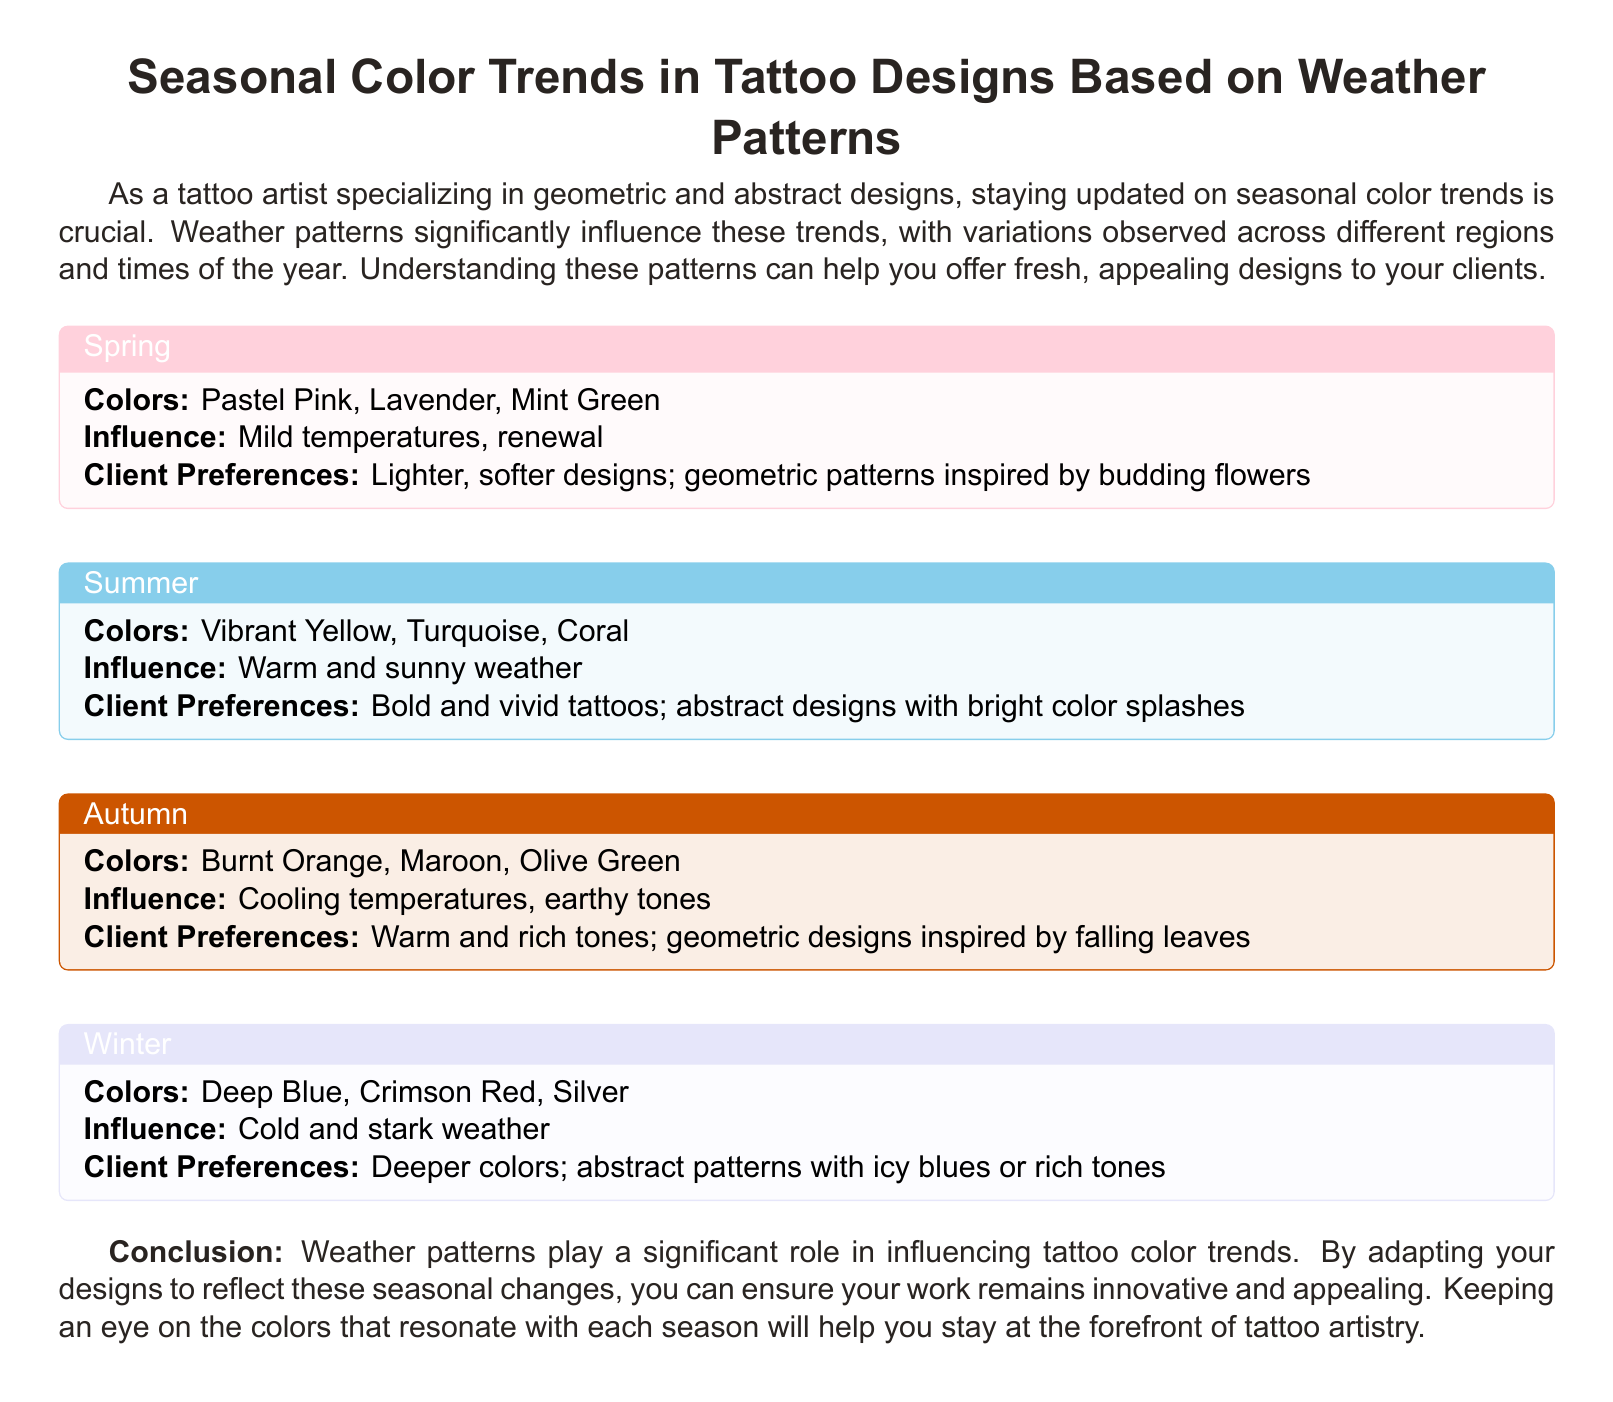What are the colors associated with Spring? The section on Spring lists the colors that are prominent during that season for tattoo designs.
Answer: Pastel Pink, Lavender, Mint Green What client preferences are noted for Summer tattoos? The section on Summer outlines what clients typically seek for tattoos in that season.
Answer: Bold and vivid tattoos; abstract designs with bright color splashes Which influence is mentioned for Autumn? The Autumn section specifies the environmental changes that inspire design choices during that season.
Answer: Cooling temperatures, earthy tones What colors are recommended for Winter tattoos? The document lists specific colors suitable for tattoo designs in that season.
Answer: Deep Blue, Crimson Red, Silver How does weather influence tattoo color trends? The introduction explains the relationship between weather patterns and tattoo design preferences.
Answer: Weather patterns play a significant role What season features colors inspired by blooming flowers? The Spring section highlights the thematic inspiration drawn from the environment during that season.
Answer: Spring What are the colors for Autumn designs? The document lists specific colors that characterize tattoo designs inspired by Autumn.
Answer: Burnt Orange, Maroon, Olive Green Which season is associated with vibrant colors? The Summer section explicitly mentions the bold color palette tied to this season.
Answer: Summer What does the conclusion suggest for tattoo artists? The conclusion summarizes the overall advice provided in the document for staying relevant in tattoo artistry.
Answer: Adapt designs to reflect seasonal changes 